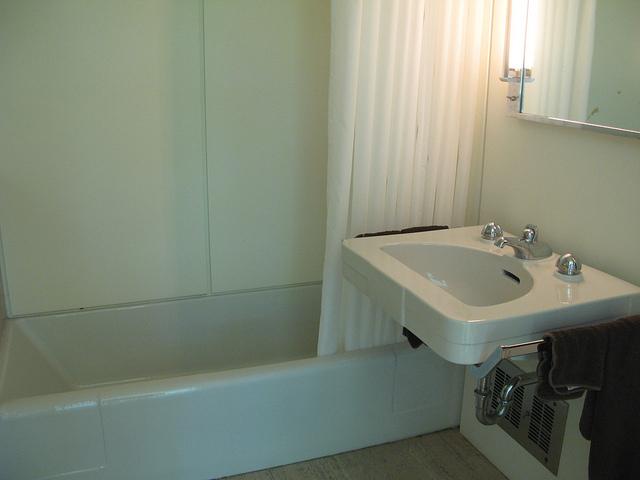Is there a washcloth?
Be succinct. No. Does this bathroom need to be redone?
Quick response, please. No. How many sinks are here?
Concise answer only. 1. Is there a toilet in the picture?
Short answer required. No. Are the sinks lonely?
Concise answer only. No. What color are the towel and washcloth?
Short answer required. Brown. What is under the sink?
Concise answer only. Pipes. Are there any towels pictured?
Give a very brief answer. No. What is the color of the bathroom?
Answer briefly. White. Is this a low budget bathroom?
Keep it brief. Yes. Are the curtains open?
Give a very brief answer. Yes. Is the shower curtain open?
Keep it brief. Yes. Is this a modern bathroom?
Answer briefly. Yes. What room is this?
Answer briefly. Bathroom. How many sinks are there?
Be succinct. 1. 